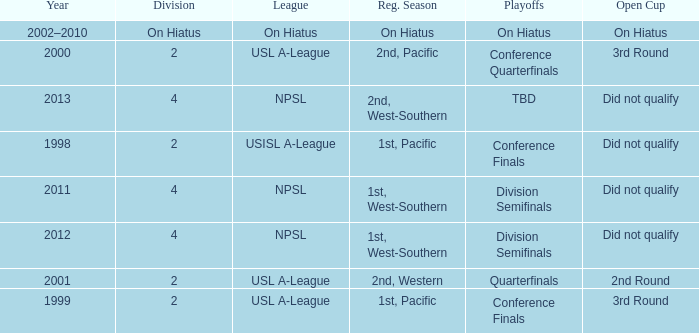Which playoffs took place during 2011? Division Semifinals. Would you be able to parse every entry in this table? {'header': ['Year', 'Division', 'League', 'Reg. Season', 'Playoffs', 'Open Cup'], 'rows': [['2002–2010', 'On Hiatus', 'On Hiatus', 'On Hiatus', 'On Hiatus', 'On Hiatus'], ['2000', '2', 'USL A-League', '2nd, Pacific', 'Conference Quarterfinals', '3rd Round'], ['2013', '4', 'NPSL', '2nd, West-Southern', 'TBD', 'Did not qualify'], ['1998', '2', 'USISL A-League', '1st, Pacific', 'Conference Finals', 'Did not qualify'], ['2011', '4', 'NPSL', '1st, West-Southern', 'Division Semifinals', 'Did not qualify'], ['2012', '4', 'NPSL', '1st, West-Southern', 'Division Semifinals', 'Did not qualify'], ['2001', '2', 'USL A-League', '2nd, Western', 'Quarterfinals', '2nd Round'], ['1999', '2', 'USL A-League', '1st, Pacific', 'Conference Finals', '3rd Round']]} 